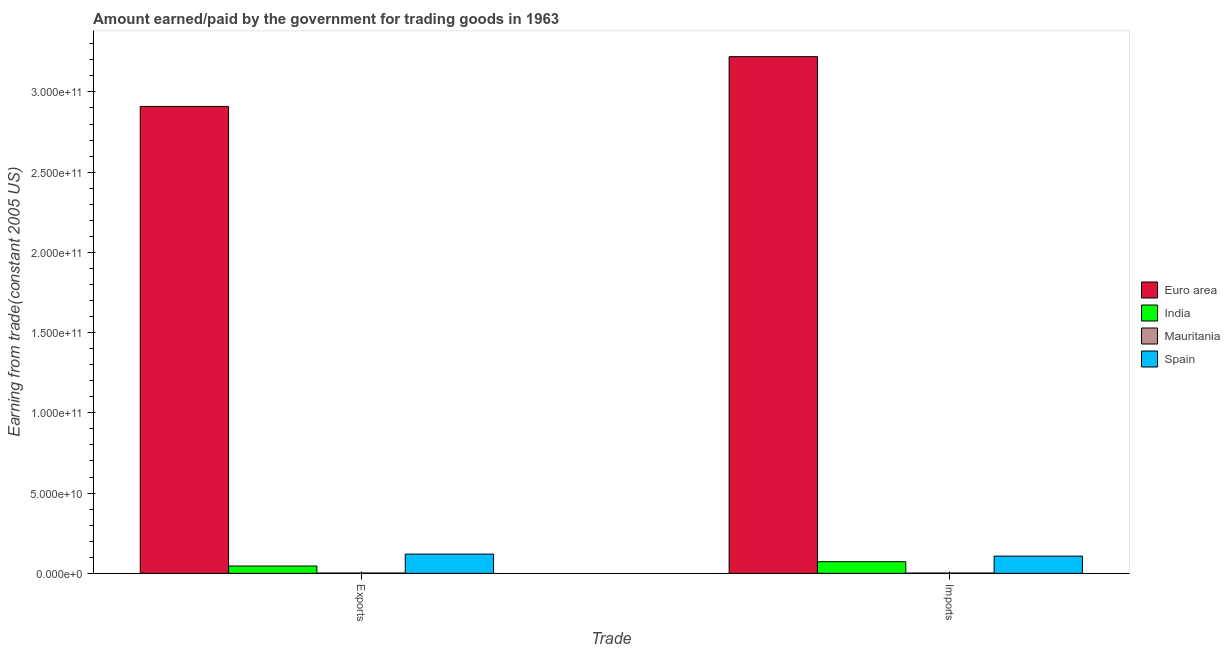Are the number of bars per tick equal to the number of legend labels?
Your response must be concise. Yes. Are the number of bars on each tick of the X-axis equal?
Provide a short and direct response. Yes. How many bars are there on the 1st tick from the left?
Make the answer very short. 4. What is the label of the 1st group of bars from the left?
Your response must be concise. Exports. What is the amount paid for imports in Spain?
Provide a succinct answer. 1.07e+1. Across all countries, what is the maximum amount paid for imports?
Your answer should be compact. 3.22e+11. Across all countries, what is the minimum amount earned from exports?
Keep it short and to the point. 1.69e+08. In which country was the amount paid for imports maximum?
Keep it short and to the point. Euro area. In which country was the amount earned from exports minimum?
Make the answer very short. Mauritania. What is the total amount earned from exports in the graph?
Offer a very short reply. 3.08e+11. What is the difference between the amount paid for imports in Spain and that in India?
Your answer should be very brief. 3.48e+09. What is the difference between the amount earned from exports in Spain and the amount paid for imports in Mauritania?
Provide a succinct answer. 1.18e+1. What is the average amount earned from exports per country?
Your response must be concise. 7.69e+1. What is the difference between the amount earned from exports and amount paid for imports in India?
Provide a short and direct response. -2.70e+09. In how many countries, is the amount paid for imports greater than 120000000000 US$?
Make the answer very short. 1. What is the ratio of the amount earned from exports in Mauritania to that in India?
Offer a terse response. 0.04. Is the amount paid for imports in Spain less than that in Mauritania?
Your response must be concise. No. In how many countries, is the amount paid for imports greater than the average amount paid for imports taken over all countries?
Ensure brevity in your answer.  1. What does the 3rd bar from the left in Exports represents?
Your answer should be compact. Mauritania. Are all the bars in the graph horizontal?
Offer a terse response. No. What is the difference between two consecutive major ticks on the Y-axis?
Your answer should be compact. 5.00e+1. Are the values on the major ticks of Y-axis written in scientific E-notation?
Make the answer very short. Yes. Does the graph contain any zero values?
Your answer should be very brief. No. Does the graph contain grids?
Make the answer very short. No. Where does the legend appear in the graph?
Keep it short and to the point. Center right. How are the legend labels stacked?
Your answer should be very brief. Vertical. What is the title of the graph?
Provide a short and direct response. Amount earned/paid by the government for trading goods in 1963. What is the label or title of the X-axis?
Provide a succinct answer. Trade. What is the label or title of the Y-axis?
Offer a very short reply. Earning from trade(constant 2005 US). What is the Earning from trade(constant 2005 US) in Euro area in Exports?
Provide a succinct answer. 2.91e+11. What is the Earning from trade(constant 2005 US) of India in Exports?
Make the answer very short. 4.56e+09. What is the Earning from trade(constant 2005 US) of Mauritania in Exports?
Offer a very short reply. 1.69e+08. What is the Earning from trade(constant 2005 US) of Spain in Exports?
Make the answer very short. 1.20e+1. What is the Earning from trade(constant 2005 US) of Euro area in Imports?
Your answer should be compact. 3.22e+11. What is the Earning from trade(constant 2005 US) in India in Imports?
Offer a terse response. 7.25e+09. What is the Earning from trade(constant 2005 US) in Mauritania in Imports?
Keep it short and to the point. 1.60e+08. What is the Earning from trade(constant 2005 US) in Spain in Imports?
Offer a very short reply. 1.07e+1. Across all Trade, what is the maximum Earning from trade(constant 2005 US) in Euro area?
Provide a succinct answer. 3.22e+11. Across all Trade, what is the maximum Earning from trade(constant 2005 US) of India?
Ensure brevity in your answer.  7.25e+09. Across all Trade, what is the maximum Earning from trade(constant 2005 US) of Mauritania?
Offer a terse response. 1.69e+08. Across all Trade, what is the maximum Earning from trade(constant 2005 US) in Spain?
Offer a very short reply. 1.20e+1. Across all Trade, what is the minimum Earning from trade(constant 2005 US) of Euro area?
Your response must be concise. 2.91e+11. Across all Trade, what is the minimum Earning from trade(constant 2005 US) in India?
Your answer should be compact. 4.56e+09. Across all Trade, what is the minimum Earning from trade(constant 2005 US) in Mauritania?
Give a very brief answer. 1.60e+08. Across all Trade, what is the minimum Earning from trade(constant 2005 US) of Spain?
Make the answer very short. 1.07e+1. What is the total Earning from trade(constant 2005 US) of Euro area in the graph?
Provide a short and direct response. 6.13e+11. What is the total Earning from trade(constant 2005 US) of India in the graph?
Your answer should be very brief. 1.18e+1. What is the total Earning from trade(constant 2005 US) in Mauritania in the graph?
Your response must be concise. 3.28e+08. What is the total Earning from trade(constant 2005 US) of Spain in the graph?
Provide a short and direct response. 2.27e+1. What is the difference between the Earning from trade(constant 2005 US) in Euro area in Exports and that in Imports?
Make the answer very short. -3.10e+1. What is the difference between the Earning from trade(constant 2005 US) in India in Exports and that in Imports?
Your response must be concise. -2.70e+09. What is the difference between the Earning from trade(constant 2005 US) of Mauritania in Exports and that in Imports?
Make the answer very short. 9.06e+06. What is the difference between the Earning from trade(constant 2005 US) of Spain in Exports and that in Imports?
Offer a very short reply. 1.25e+09. What is the difference between the Earning from trade(constant 2005 US) in Euro area in Exports and the Earning from trade(constant 2005 US) in India in Imports?
Your answer should be compact. 2.84e+11. What is the difference between the Earning from trade(constant 2005 US) in Euro area in Exports and the Earning from trade(constant 2005 US) in Mauritania in Imports?
Make the answer very short. 2.91e+11. What is the difference between the Earning from trade(constant 2005 US) of Euro area in Exports and the Earning from trade(constant 2005 US) of Spain in Imports?
Offer a very short reply. 2.80e+11. What is the difference between the Earning from trade(constant 2005 US) in India in Exports and the Earning from trade(constant 2005 US) in Mauritania in Imports?
Make the answer very short. 4.40e+09. What is the difference between the Earning from trade(constant 2005 US) in India in Exports and the Earning from trade(constant 2005 US) in Spain in Imports?
Offer a terse response. -6.17e+09. What is the difference between the Earning from trade(constant 2005 US) in Mauritania in Exports and the Earning from trade(constant 2005 US) in Spain in Imports?
Your answer should be compact. -1.06e+1. What is the average Earning from trade(constant 2005 US) of Euro area per Trade?
Give a very brief answer. 3.06e+11. What is the average Earning from trade(constant 2005 US) of India per Trade?
Ensure brevity in your answer.  5.90e+09. What is the average Earning from trade(constant 2005 US) of Mauritania per Trade?
Give a very brief answer. 1.64e+08. What is the average Earning from trade(constant 2005 US) in Spain per Trade?
Your answer should be very brief. 1.14e+1. What is the difference between the Earning from trade(constant 2005 US) of Euro area and Earning from trade(constant 2005 US) of India in Exports?
Ensure brevity in your answer.  2.86e+11. What is the difference between the Earning from trade(constant 2005 US) in Euro area and Earning from trade(constant 2005 US) in Mauritania in Exports?
Keep it short and to the point. 2.91e+11. What is the difference between the Earning from trade(constant 2005 US) of Euro area and Earning from trade(constant 2005 US) of Spain in Exports?
Your answer should be very brief. 2.79e+11. What is the difference between the Earning from trade(constant 2005 US) of India and Earning from trade(constant 2005 US) of Mauritania in Exports?
Give a very brief answer. 4.39e+09. What is the difference between the Earning from trade(constant 2005 US) in India and Earning from trade(constant 2005 US) in Spain in Exports?
Provide a short and direct response. -7.43e+09. What is the difference between the Earning from trade(constant 2005 US) in Mauritania and Earning from trade(constant 2005 US) in Spain in Exports?
Your answer should be compact. -1.18e+1. What is the difference between the Earning from trade(constant 2005 US) in Euro area and Earning from trade(constant 2005 US) in India in Imports?
Keep it short and to the point. 3.15e+11. What is the difference between the Earning from trade(constant 2005 US) of Euro area and Earning from trade(constant 2005 US) of Mauritania in Imports?
Your answer should be very brief. 3.22e+11. What is the difference between the Earning from trade(constant 2005 US) of Euro area and Earning from trade(constant 2005 US) of Spain in Imports?
Your answer should be compact. 3.11e+11. What is the difference between the Earning from trade(constant 2005 US) in India and Earning from trade(constant 2005 US) in Mauritania in Imports?
Make the answer very short. 7.09e+09. What is the difference between the Earning from trade(constant 2005 US) of India and Earning from trade(constant 2005 US) of Spain in Imports?
Your answer should be compact. -3.48e+09. What is the difference between the Earning from trade(constant 2005 US) of Mauritania and Earning from trade(constant 2005 US) of Spain in Imports?
Your response must be concise. -1.06e+1. What is the ratio of the Earning from trade(constant 2005 US) in Euro area in Exports to that in Imports?
Provide a short and direct response. 0.9. What is the ratio of the Earning from trade(constant 2005 US) of India in Exports to that in Imports?
Provide a short and direct response. 0.63. What is the ratio of the Earning from trade(constant 2005 US) in Mauritania in Exports to that in Imports?
Your response must be concise. 1.06. What is the ratio of the Earning from trade(constant 2005 US) in Spain in Exports to that in Imports?
Your response must be concise. 1.12. What is the difference between the highest and the second highest Earning from trade(constant 2005 US) of Euro area?
Offer a very short reply. 3.10e+1. What is the difference between the highest and the second highest Earning from trade(constant 2005 US) of India?
Your response must be concise. 2.70e+09. What is the difference between the highest and the second highest Earning from trade(constant 2005 US) of Mauritania?
Provide a short and direct response. 9.06e+06. What is the difference between the highest and the second highest Earning from trade(constant 2005 US) of Spain?
Keep it short and to the point. 1.25e+09. What is the difference between the highest and the lowest Earning from trade(constant 2005 US) of Euro area?
Provide a succinct answer. 3.10e+1. What is the difference between the highest and the lowest Earning from trade(constant 2005 US) of India?
Provide a short and direct response. 2.70e+09. What is the difference between the highest and the lowest Earning from trade(constant 2005 US) of Mauritania?
Offer a very short reply. 9.06e+06. What is the difference between the highest and the lowest Earning from trade(constant 2005 US) in Spain?
Provide a short and direct response. 1.25e+09. 